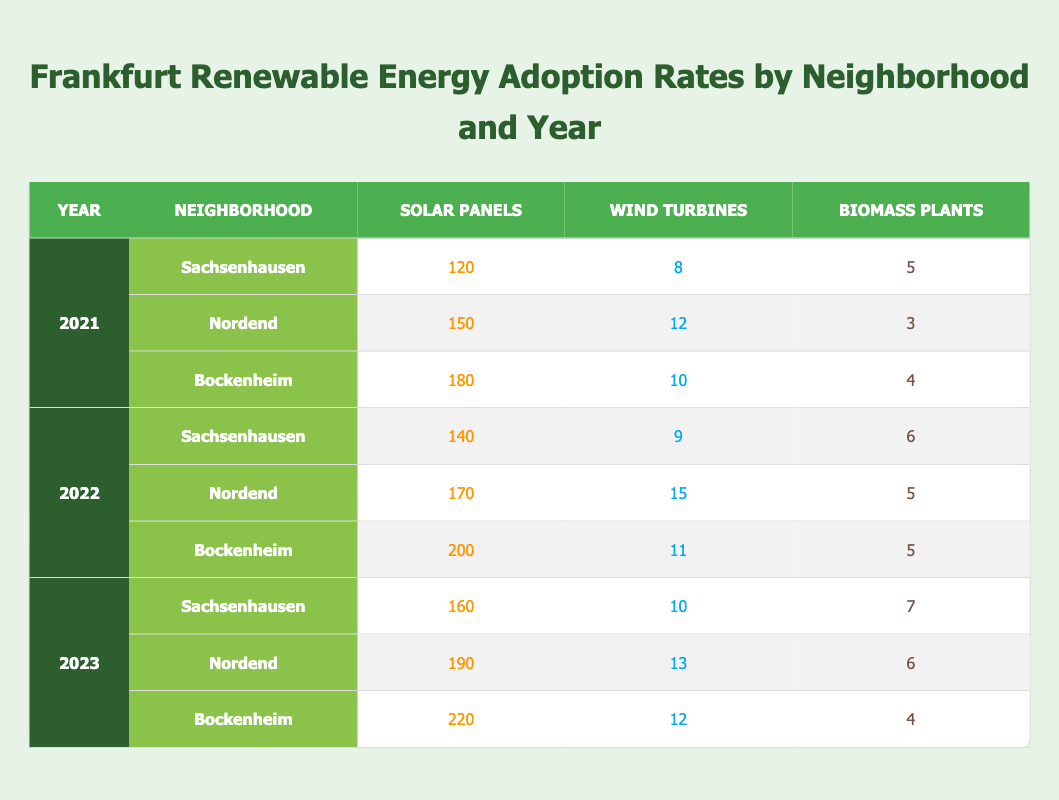What is the total number of solar panels installed in Sachsenhausen in 2022? In 2022, Sachsenhausen had 140 solar panels installed.
Answer: 140 How many wind turbines were installed in Nordend in 2023? In 2023, Nordend had 13 wind turbines installed.
Answer: 13 Which neighborhood had the highest number of biomass plants in 2021? In 2021, Sachsenhausen had 5 biomass plants, Nordend had 3, and Bockenheim had 4, so Sachsenhausen had the highest number.
Answer: Sachsenhausen What is the total number of wind turbines across all neighborhoods in 2022? In 2022, Sachsenhausen had 9, Nordend had 15, and Bockenheim had 11, adding them gives 9 + 15 + 11 = 35.
Answer: 35 True or False: Bockenheim had more solar panels in 2023 than in 2022. In 2023, Bockenheim had 220 solar panels, while in 2022 it had 200, hence it is true that Bockenheim had more solar panels in 2023.
Answer: True What is the difference in the number of solar panels installed in Nordend between 2021 and 2023? In 2021, Nordend had 150 solar panels and in 2023 it had 190, the difference is 190 - 150 = 40.
Answer: 40 Which neighborhood showed the largest increase in solar panel installations from 2021 to 2023? Sachsenhausen had 120 solar panels in 2021 and 160 in 2023, which is an increase of 40. Nordend had an increase of 40 as well (150 to 190), while Bockenheim had an increase of 40 (180 to 220). All three neighborhoods increased by 40 panels.
Answer: Sachsenhausen, Nordend, Bockenheim What was the average number of biomass plants across all neighborhoods in 2023? In 2023, Sachsenhausen had 7, Nordend had 6, and Bockenheim had 4. Summing these gives 7 + 6 + 4 = 17, dividing by the 3 neighborhoods gives an average of 17 / 3 ≈ 5.67, so the average is approximately 5.67.
Answer: 5.67 